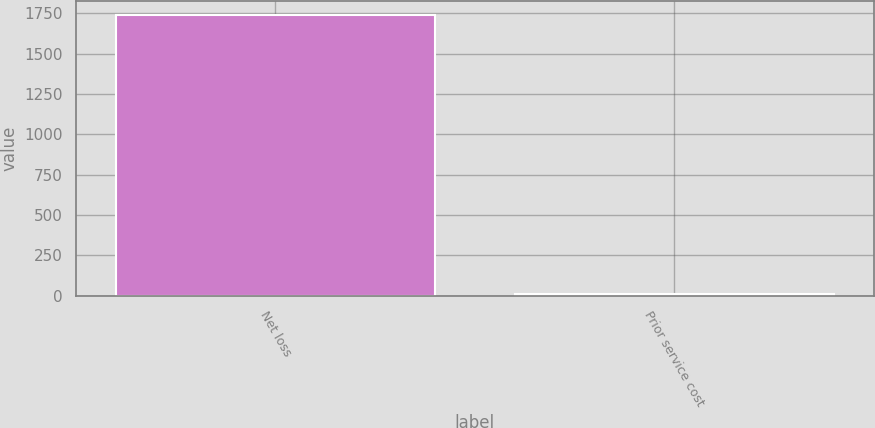Convert chart. <chart><loc_0><loc_0><loc_500><loc_500><bar_chart><fcel>Net loss<fcel>Prior service cost<nl><fcel>1737<fcel>11<nl></chart> 